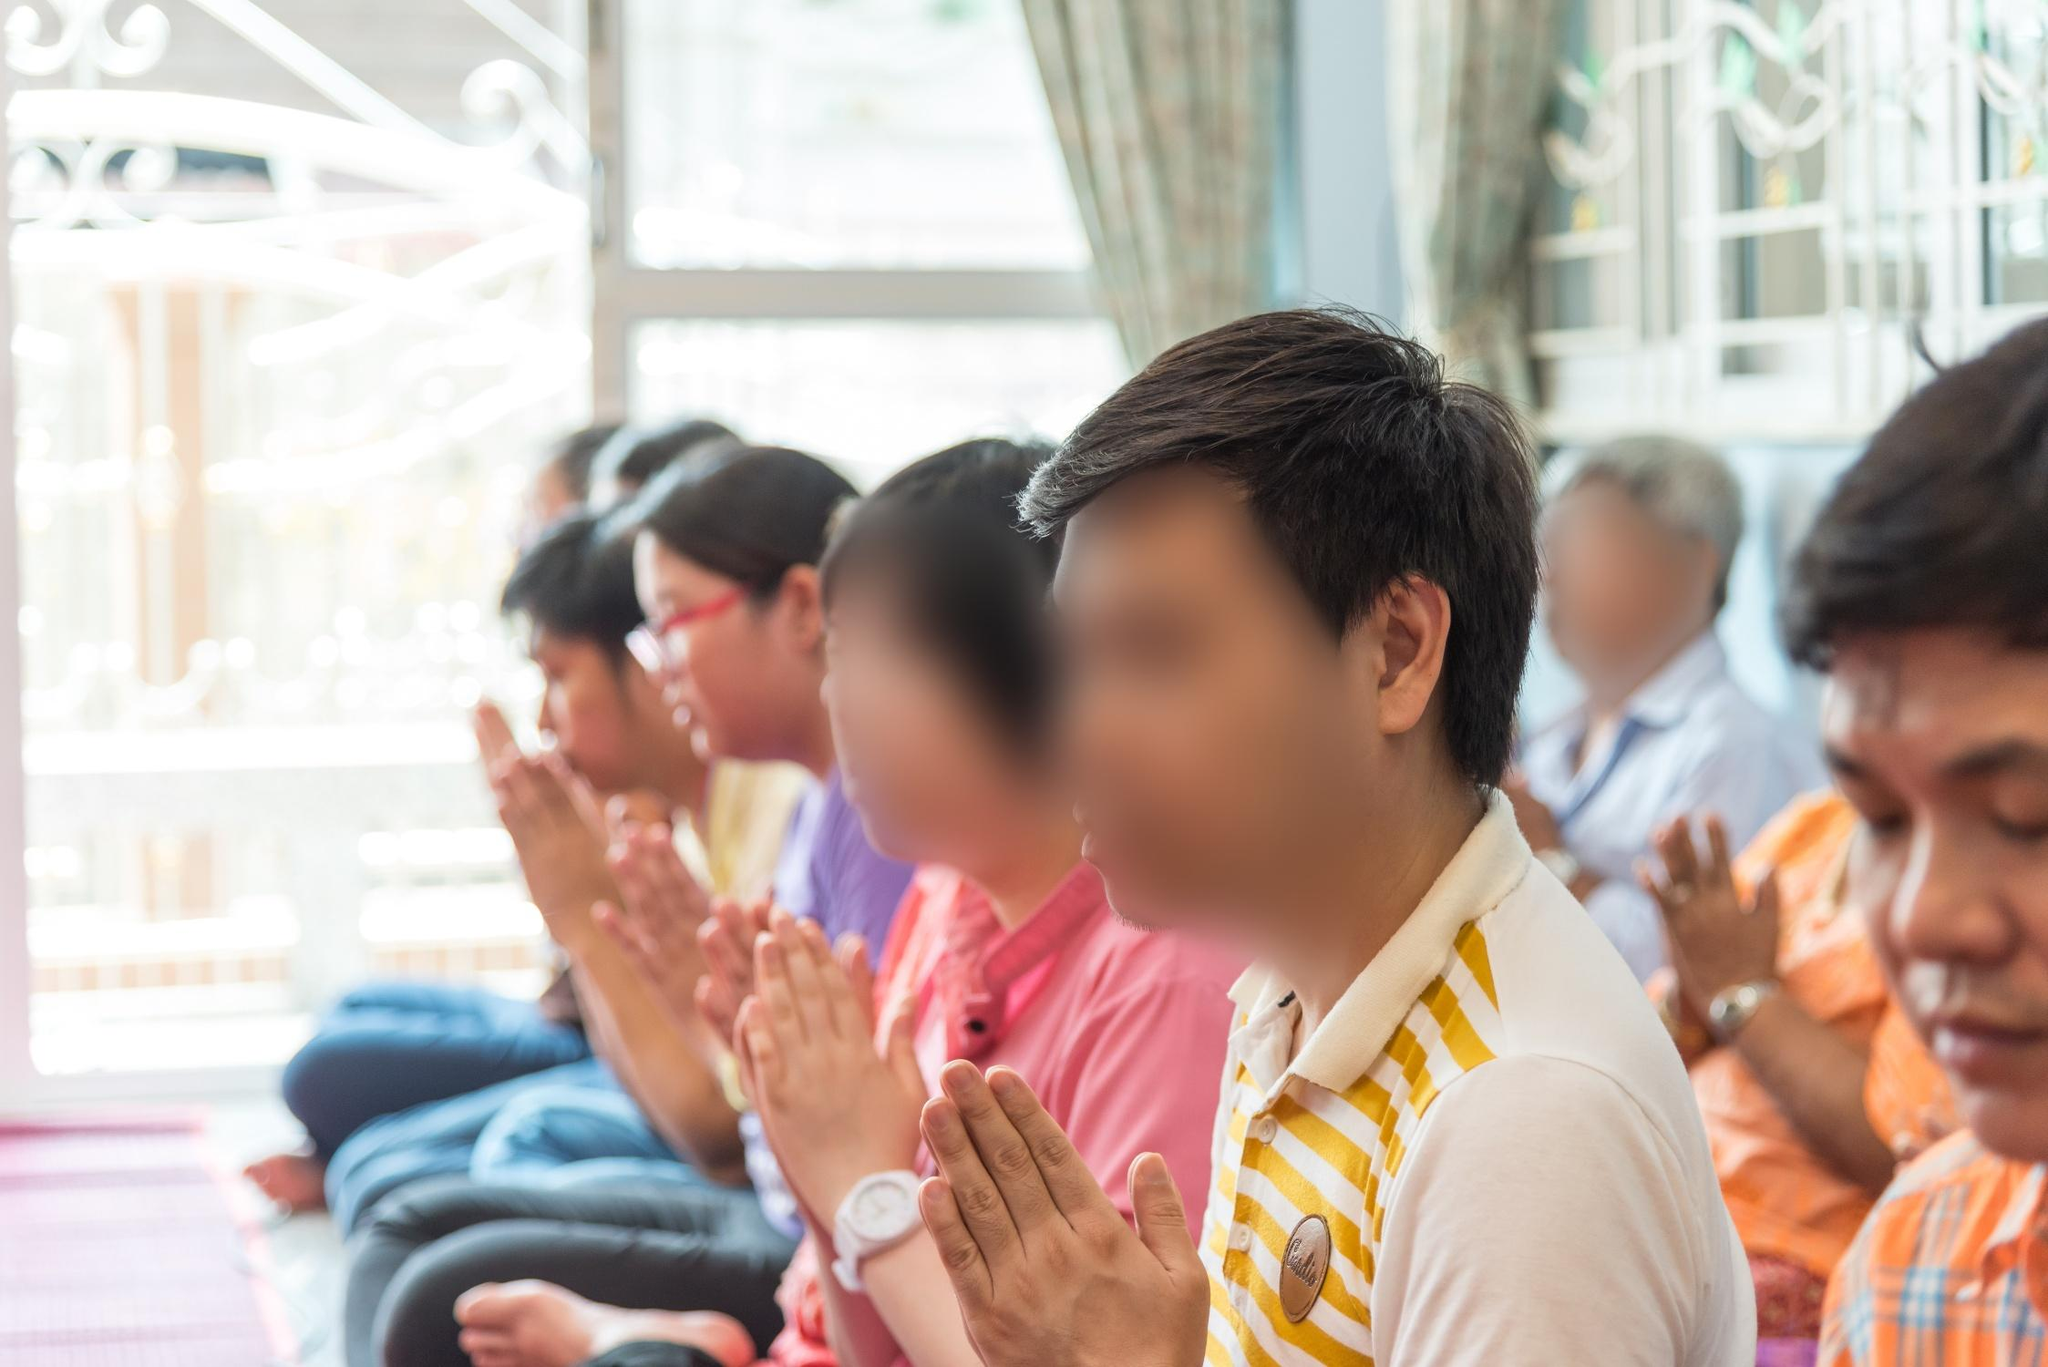If this image had a soundtrack, what would it sound like? The soundtrack accompanying this image would likely be characterized by soft, melodious chanting or recitations of prayers, creating a soothing and meditative auditory backdrop. The gentle rustle of fabrics as people adjust their seating, coupled with the faint sounds of nature like birds chirping or a distant bell, might enhance the serene atmosphere. This audio would evoke a deep sense of calm, reflective of the spiritual devotion captured in the scene. Imagine a mystical element added to this scene. Describe it. In this tranquil setting, imagine a soft, ethereal glow enveloping the praying individuals, slowly rising from the ground and illuminating their serene faces. Sparks of gentle, shimmering light would float in the air, converging above their heads to form intricate, glowing symbols of faith and unity. These symbols would shift and dance gracefully, symbolizing the divine presence and blessing their prayers. The atmosphere would be imbued with a sense of mystical reverence, making the spiritual connection in the room palpably sacred and transformative. 